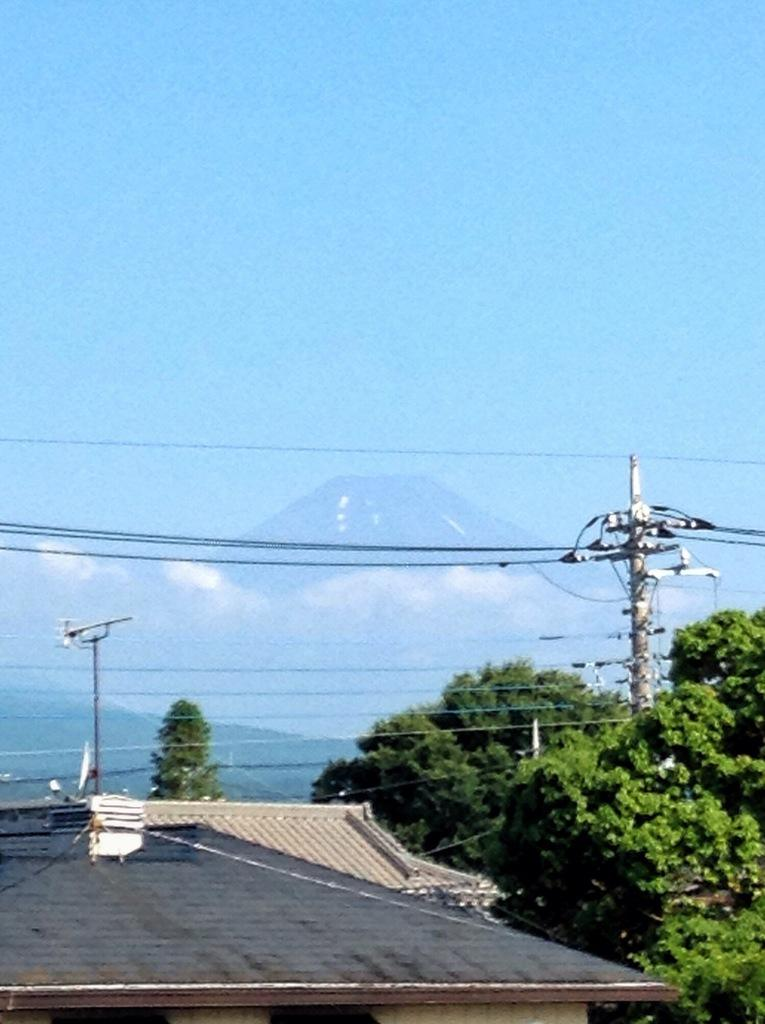What type of structure is present in the image? There is a house in the image. What other objects can be seen in the image? There are electrical poles, trees, and mountains in the image. What is visible in the background of the image? The sky is visible in the background of the image. What type of finger can be seen pointing at the mountains in the image? There are no fingers visible in the image; it only features a house, electrical poles, trees, mountains, and the sky. 